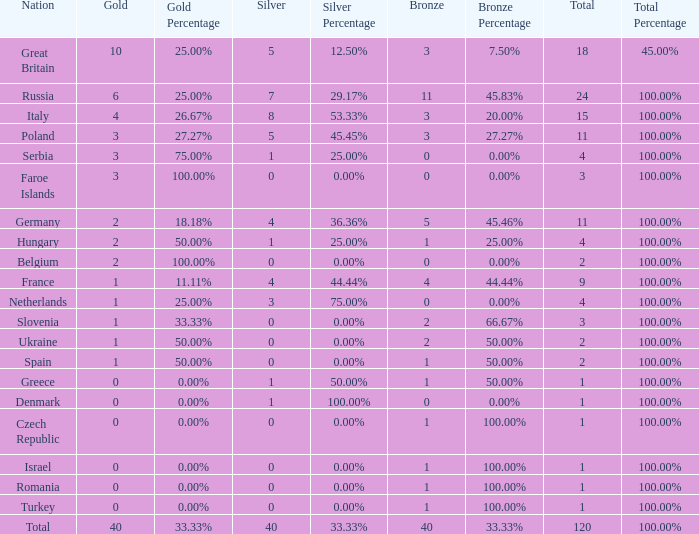What is Turkey's average Gold entry that also has a Bronze entry that is smaller than 2 and the Total is greater than 1? None. 